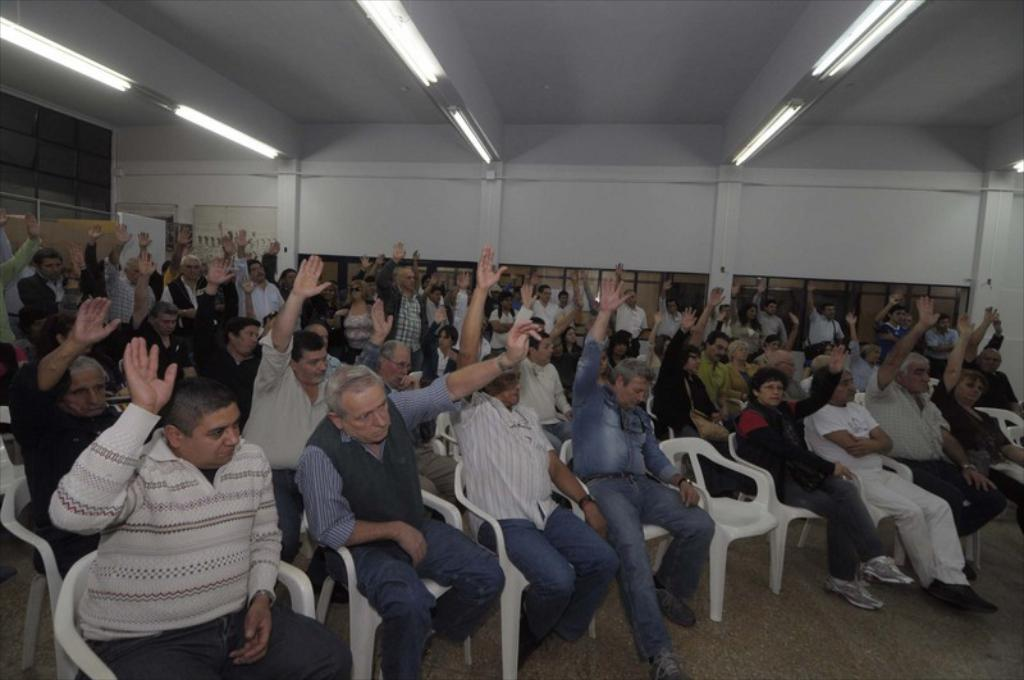What are the people in the image doing? There are many persons sitting on chairs in the image. Can you describe the person in the background? There is a person standing in the background of the image. What architectural features can be seen in the background? There are pillars, a wall, windows, and lights visible in the background of the image. What note is the person sitting on the chair playing on their instrument? There is no instrument or note mentioned in the image; people are simply sitting on chairs. How does the wall in the background wash itself? The wall in the background does not wash itself; it is a stationary architectural feature. 